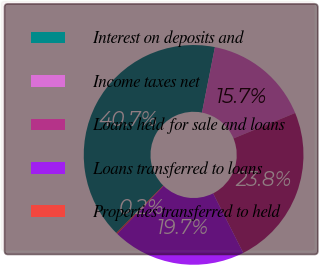<chart> <loc_0><loc_0><loc_500><loc_500><pie_chart><fcel>Interest on deposits and<fcel>Income taxes net<fcel>Loans held for sale and loans<fcel>Loans transferred to loans<fcel>Properties transferred to held<nl><fcel>40.69%<fcel>15.66%<fcel>23.77%<fcel>19.71%<fcel>0.17%<nl></chart> 